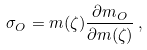Convert formula to latex. <formula><loc_0><loc_0><loc_500><loc_500>\sigma _ { O } = m ( \zeta ) \frac { \partial m _ { O } } { \partial m ( \zeta ) } \, ,</formula> 